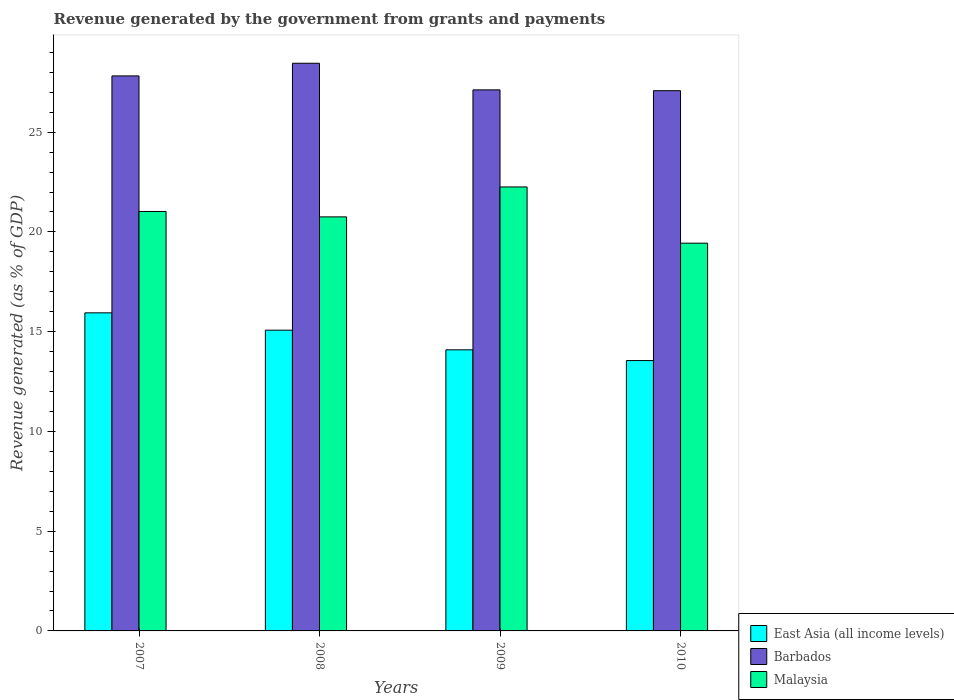How many groups of bars are there?
Your answer should be compact. 4. Are the number of bars per tick equal to the number of legend labels?
Offer a terse response. Yes. Are the number of bars on each tick of the X-axis equal?
Ensure brevity in your answer.  Yes. How many bars are there on the 1st tick from the left?
Ensure brevity in your answer.  3. What is the label of the 3rd group of bars from the left?
Offer a terse response. 2009. In how many cases, is the number of bars for a given year not equal to the number of legend labels?
Offer a very short reply. 0. What is the revenue generated by the government in Malaysia in 2009?
Give a very brief answer. 22.25. Across all years, what is the maximum revenue generated by the government in Malaysia?
Ensure brevity in your answer.  22.25. Across all years, what is the minimum revenue generated by the government in Barbados?
Offer a very short reply. 27.08. In which year was the revenue generated by the government in Malaysia maximum?
Make the answer very short. 2009. In which year was the revenue generated by the government in East Asia (all income levels) minimum?
Offer a terse response. 2010. What is the total revenue generated by the government in Barbados in the graph?
Your answer should be compact. 110.47. What is the difference between the revenue generated by the government in Malaysia in 2007 and that in 2010?
Ensure brevity in your answer.  1.59. What is the difference between the revenue generated by the government in Malaysia in 2008 and the revenue generated by the government in Barbados in 2009?
Your response must be concise. -6.37. What is the average revenue generated by the government in Malaysia per year?
Provide a succinct answer. 20.87. In the year 2009, what is the difference between the revenue generated by the government in Malaysia and revenue generated by the government in Barbados?
Give a very brief answer. -4.87. What is the ratio of the revenue generated by the government in Malaysia in 2007 to that in 2009?
Your answer should be very brief. 0.94. Is the revenue generated by the government in Barbados in 2009 less than that in 2010?
Ensure brevity in your answer.  No. Is the difference between the revenue generated by the government in Malaysia in 2007 and 2010 greater than the difference between the revenue generated by the government in Barbados in 2007 and 2010?
Your response must be concise. Yes. What is the difference between the highest and the second highest revenue generated by the government in Malaysia?
Your answer should be very brief. 1.23. What is the difference between the highest and the lowest revenue generated by the government in Malaysia?
Ensure brevity in your answer.  2.82. Is the sum of the revenue generated by the government in Malaysia in 2007 and 2008 greater than the maximum revenue generated by the government in East Asia (all income levels) across all years?
Keep it short and to the point. Yes. What does the 2nd bar from the left in 2008 represents?
Your answer should be very brief. Barbados. What does the 3rd bar from the right in 2007 represents?
Your answer should be compact. East Asia (all income levels). Is it the case that in every year, the sum of the revenue generated by the government in Barbados and revenue generated by the government in Malaysia is greater than the revenue generated by the government in East Asia (all income levels)?
Your response must be concise. Yes. How many years are there in the graph?
Your response must be concise. 4. Does the graph contain any zero values?
Make the answer very short. No. Does the graph contain grids?
Ensure brevity in your answer.  No. Where does the legend appear in the graph?
Your response must be concise. Bottom right. How many legend labels are there?
Your answer should be compact. 3. What is the title of the graph?
Keep it short and to the point. Revenue generated by the government from grants and payments. Does "Qatar" appear as one of the legend labels in the graph?
Ensure brevity in your answer.  No. What is the label or title of the Y-axis?
Offer a very short reply. Revenue generated (as % of GDP). What is the Revenue generated (as % of GDP) of East Asia (all income levels) in 2007?
Offer a very short reply. 15.94. What is the Revenue generated (as % of GDP) of Barbados in 2007?
Provide a short and direct response. 27.82. What is the Revenue generated (as % of GDP) of Malaysia in 2007?
Provide a succinct answer. 21.02. What is the Revenue generated (as % of GDP) in East Asia (all income levels) in 2008?
Make the answer very short. 15.07. What is the Revenue generated (as % of GDP) of Barbados in 2008?
Ensure brevity in your answer.  28.45. What is the Revenue generated (as % of GDP) of Malaysia in 2008?
Your answer should be compact. 20.75. What is the Revenue generated (as % of GDP) of East Asia (all income levels) in 2009?
Offer a terse response. 14.09. What is the Revenue generated (as % of GDP) in Barbados in 2009?
Offer a very short reply. 27.12. What is the Revenue generated (as % of GDP) in Malaysia in 2009?
Make the answer very short. 22.25. What is the Revenue generated (as % of GDP) of East Asia (all income levels) in 2010?
Give a very brief answer. 13.55. What is the Revenue generated (as % of GDP) in Barbados in 2010?
Offer a very short reply. 27.08. What is the Revenue generated (as % of GDP) in Malaysia in 2010?
Make the answer very short. 19.44. Across all years, what is the maximum Revenue generated (as % of GDP) in East Asia (all income levels)?
Ensure brevity in your answer.  15.94. Across all years, what is the maximum Revenue generated (as % of GDP) of Barbados?
Provide a short and direct response. 28.45. Across all years, what is the maximum Revenue generated (as % of GDP) of Malaysia?
Your response must be concise. 22.25. Across all years, what is the minimum Revenue generated (as % of GDP) in East Asia (all income levels)?
Your response must be concise. 13.55. Across all years, what is the minimum Revenue generated (as % of GDP) in Barbados?
Make the answer very short. 27.08. Across all years, what is the minimum Revenue generated (as % of GDP) in Malaysia?
Provide a succinct answer. 19.44. What is the total Revenue generated (as % of GDP) in East Asia (all income levels) in the graph?
Make the answer very short. 58.66. What is the total Revenue generated (as % of GDP) of Barbados in the graph?
Offer a terse response. 110.47. What is the total Revenue generated (as % of GDP) of Malaysia in the graph?
Offer a very short reply. 83.47. What is the difference between the Revenue generated (as % of GDP) of East Asia (all income levels) in 2007 and that in 2008?
Your response must be concise. 0.87. What is the difference between the Revenue generated (as % of GDP) in Barbados in 2007 and that in 2008?
Give a very brief answer. -0.63. What is the difference between the Revenue generated (as % of GDP) in Malaysia in 2007 and that in 2008?
Make the answer very short. 0.27. What is the difference between the Revenue generated (as % of GDP) of East Asia (all income levels) in 2007 and that in 2009?
Make the answer very short. 1.85. What is the difference between the Revenue generated (as % of GDP) in Barbados in 2007 and that in 2009?
Provide a succinct answer. 0.7. What is the difference between the Revenue generated (as % of GDP) of Malaysia in 2007 and that in 2009?
Provide a short and direct response. -1.23. What is the difference between the Revenue generated (as % of GDP) of East Asia (all income levels) in 2007 and that in 2010?
Offer a terse response. 2.39. What is the difference between the Revenue generated (as % of GDP) of Barbados in 2007 and that in 2010?
Provide a succinct answer. 0.74. What is the difference between the Revenue generated (as % of GDP) of Malaysia in 2007 and that in 2010?
Your response must be concise. 1.59. What is the difference between the Revenue generated (as % of GDP) in East Asia (all income levels) in 2008 and that in 2009?
Your answer should be compact. 0.99. What is the difference between the Revenue generated (as % of GDP) of Barbados in 2008 and that in 2009?
Give a very brief answer. 1.33. What is the difference between the Revenue generated (as % of GDP) in Malaysia in 2008 and that in 2009?
Your response must be concise. -1.5. What is the difference between the Revenue generated (as % of GDP) in East Asia (all income levels) in 2008 and that in 2010?
Provide a short and direct response. 1.52. What is the difference between the Revenue generated (as % of GDP) in Barbados in 2008 and that in 2010?
Provide a short and direct response. 1.38. What is the difference between the Revenue generated (as % of GDP) in Malaysia in 2008 and that in 2010?
Provide a succinct answer. 1.32. What is the difference between the Revenue generated (as % of GDP) of East Asia (all income levels) in 2009 and that in 2010?
Ensure brevity in your answer.  0.54. What is the difference between the Revenue generated (as % of GDP) of Barbados in 2009 and that in 2010?
Make the answer very short. 0.04. What is the difference between the Revenue generated (as % of GDP) in Malaysia in 2009 and that in 2010?
Make the answer very short. 2.82. What is the difference between the Revenue generated (as % of GDP) of East Asia (all income levels) in 2007 and the Revenue generated (as % of GDP) of Barbados in 2008?
Your answer should be very brief. -12.51. What is the difference between the Revenue generated (as % of GDP) of East Asia (all income levels) in 2007 and the Revenue generated (as % of GDP) of Malaysia in 2008?
Your answer should be compact. -4.81. What is the difference between the Revenue generated (as % of GDP) in Barbados in 2007 and the Revenue generated (as % of GDP) in Malaysia in 2008?
Your response must be concise. 7.07. What is the difference between the Revenue generated (as % of GDP) in East Asia (all income levels) in 2007 and the Revenue generated (as % of GDP) in Barbados in 2009?
Provide a succinct answer. -11.18. What is the difference between the Revenue generated (as % of GDP) in East Asia (all income levels) in 2007 and the Revenue generated (as % of GDP) in Malaysia in 2009?
Offer a terse response. -6.31. What is the difference between the Revenue generated (as % of GDP) of Barbados in 2007 and the Revenue generated (as % of GDP) of Malaysia in 2009?
Offer a very short reply. 5.57. What is the difference between the Revenue generated (as % of GDP) in East Asia (all income levels) in 2007 and the Revenue generated (as % of GDP) in Barbados in 2010?
Offer a terse response. -11.13. What is the difference between the Revenue generated (as % of GDP) of East Asia (all income levels) in 2007 and the Revenue generated (as % of GDP) of Malaysia in 2010?
Provide a short and direct response. -3.49. What is the difference between the Revenue generated (as % of GDP) of Barbados in 2007 and the Revenue generated (as % of GDP) of Malaysia in 2010?
Make the answer very short. 8.38. What is the difference between the Revenue generated (as % of GDP) of East Asia (all income levels) in 2008 and the Revenue generated (as % of GDP) of Barbados in 2009?
Make the answer very short. -12.04. What is the difference between the Revenue generated (as % of GDP) in East Asia (all income levels) in 2008 and the Revenue generated (as % of GDP) in Malaysia in 2009?
Offer a very short reply. -7.18. What is the difference between the Revenue generated (as % of GDP) in Barbados in 2008 and the Revenue generated (as % of GDP) in Malaysia in 2009?
Your answer should be very brief. 6.2. What is the difference between the Revenue generated (as % of GDP) in East Asia (all income levels) in 2008 and the Revenue generated (as % of GDP) in Barbados in 2010?
Keep it short and to the point. -12. What is the difference between the Revenue generated (as % of GDP) of East Asia (all income levels) in 2008 and the Revenue generated (as % of GDP) of Malaysia in 2010?
Give a very brief answer. -4.36. What is the difference between the Revenue generated (as % of GDP) of Barbados in 2008 and the Revenue generated (as % of GDP) of Malaysia in 2010?
Make the answer very short. 9.02. What is the difference between the Revenue generated (as % of GDP) in East Asia (all income levels) in 2009 and the Revenue generated (as % of GDP) in Barbados in 2010?
Offer a terse response. -12.99. What is the difference between the Revenue generated (as % of GDP) in East Asia (all income levels) in 2009 and the Revenue generated (as % of GDP) in Malaysia in 2010?
Give a very brief answer. -5.35. What is the difference between the Revenue generated (as % of GDP) in Barbados in 2009 and the Revenue generated (as % of GDP) in Malaysia in 2010?
Offer a terse response. 7.68. What is the average Revenue generated (as % of GDP) in East Asia (all income levels) per year?
Ensure brevity in your answer.  14.67. What is the average Revenue generated (as % of GDP) in Barbados per year?
Your response must be concise. 27.62. What is the average Revenue generated (as % of GDP) in Malaysia per year?
Make the answer very short. 20.87. In the year 2007, what is the difference between the Revenue generated (as % of GDP) in East Asia (all income levels) and Revenue generated (as % of GDP) in Barbados?
Your response must be concise. -11.88. In the year 2007, what is the difference between the Revenue generated (as % of GDP) of East Asia (all income levels) and Revenue generated (as % of GDP) of Malaysia?
Provide a short and direct response. -5.08. In the year 2007, what is the difference between the Revenue generated (as % of GDP) in Barbados and Revenue generated (as % of GDP) in Malaysia?
Your answer should be compact. 6.8. In the year 2008, what is the difference between the Revenue generated (as % of GDP) of East Asia (all income levels) and Revenue generated (as % of GDP) of Barbados?
Make the answer very short. -13.38. In the year 2008, what is the difference between the Revenue generated (as % of GDP) of East Asia (all income levels) and Revenue generated (as % of GDP) of Malaysia?
Ensure brevity in your answer.  -5.68. In the year 2008, what is the difference between the Revenue generated (as % of GDP) of Barbados and Revenue generated (as % of GDP) of Malaysia?
Offer a very short reply. 7.7. In the year 2009, what is the difference between the Revenue generated (as % of GDP) of East Asia (all income levels) and Revenue generated (as % of GDP) of Barbados?
Offer a terse response. -13.03. In the year 2009, what is the difference between the Revenue generated (as % of GDP) of East Asia (all income levels) and Revenue generated (as % of GDP) of Malaysia?
Keep it short and to the point. -8.16. In the year 2009, what is the difference between the Revenue generated (as % of GDP) in Barbados and Revenue generated (as % of GDP) in Malaysia?
Your answer should be compact. 4.87. In the year 2010, what is the difference between the Revenue generated (as % of GDP) in East Asia (all income levels) and Revenue generated (as % of GDP) in Barbados?
Your answer should be compact. -13.53. In the year 2010, what is the difference between the Revenue generated (as % of GDP) of East Asia (all income levels) and Revenue generated (as % of GDP) of Malaysia?
Offer a terse response. -5.88. In the year 2010, what is the difference between the Revenue generated (as % of GDP) of Barbados and Revenue generated (as % of GDP) of Malaysia?
Keep it short and to the point. 7.64. What is the ratio of the Revenue generated (as % of GDP) in East Asia (all income levels) in 2007 to that in 2008?
Ensure brevity in your answer.  1.06. What is the ratio of the Revenue generated (as % of GDP) in Barbados in 2007 to that in 2008?
Make the answer very short. 0.98. What is the ratio of the Revenue generated (as % of GDP) of Malaysia in 2007 to that in 2008?
Offer a terse response. 1.01. What is the ratio of the Revenue generated (as % of GDP) of East Asia (all income levels) in 2007 to that in 2009?
Your answer should be compact. 1.13. What is the ratio of the Revenue generated (as % of GDP) of Barbados in 2007 to that in 2009?
Offer a very short reply. 1.03. What is the ratio of the Revenue generated (as % of GDP) of Malaysia in 2007 to that in 2009?
Make the answer very short. 0.94. What is the ratio of the Revenue generated (as % of GDP) of East Asia (all income levels) in 2007 to that in 2010?
Give a very brief answer. 1.18. What is the ratio of the Revenue generated (as % of GDP) in Barbados in 2007 to that in 2010?
Your answer should be very brief. 1.03. What is the ratio of the Revenue generated (as % of GDP) of Malaysia in 2007 to that in 2010?
Provide a short and direct response. 1.08. What is the ratio of the Revenue generated (as % of GDP) in East Asia (all income levels) in 2008 to that in 2009?
Your answer should be compact. 1.07. What is the ratio of the Revenue generated (as % of GDP) of Barbados in 2008 to that in 2009?
Provide a succinct answer. 1.05. What is the ratio of the Revenue generated (as % of GDP) of Malaysia in 2008 to that in 2009?
Your response must be concise. 0.93. What is the ratio of the Revenue generated (as % of GDP) in East Asia (all income levels) in 2008 to that in 2010?
Ensure brevity in your answer.  1.11. What is the ratio of the Revenue generated (as % of GDP) of Barbados in 2008 to that in 2010?
Provide a succinct answer. 1.05. What is the ratio of the Revenue generated (as % of GDP) in Malaysia in 2008 to that in 2010?
Ensure brevity in your answer.  1.07. What is the ratio of the Revenue generated (as % of GDP) in East Asia (all income levels) in 2009 to that in 2010?
Give a very brief answer. 1.04. What is the ratio of the Revenue generated (as % of GDP) in Barbados in 2009 to that in 2010?
Ensure brevity in your answer.  1. What is the ratio of the Revenue generated (as % of GDP) of Malaysia in 2009 to that in 2010?
Keep it short and to the point. 1.15. What is the difference between the highest and the second highest Revenue generated (as % of GDP) in East Asia (all income levels)?
Provide a succinct answer. 0.87. What is the difference between the highest and the second highest Revenue generated (as % of GDP) in Barbados?
Ensure brevity in your answer.  0.63. What is the difference between the highest and the second highest Revenue generated (as % of GDP) of Malaysia?
Make the answer very short. 1.23. What is the difference between the highest and the lowest Revenue generated (as % of GDP) in East Asia (all income levels)?
Your answer should be very brief. 2.39. What is the difference between the highest and the lowest Revenue generated (as % of GDP) of Barbados?
Provide a short and direct response. 1.38. What is the difference between the highest and the lowest Revenue generated (as % of GDP) in Malaysia?
Provide a succinct answer. 2.82. 